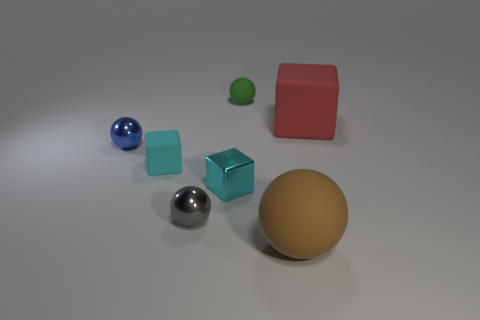How big is the metallic ball that is on the right side of the tiny blue shiny object?
Your response must be concise. Small. How many yellow things are big matte cubes or spheres?
Keep it short and to the point. 0. Are there any other things that are made of the same material as the green sphere?
Your answer should be compact. Yes. There is a blue thing that is the same shape as the brown object; what material is it?
Give a very brief answer. Metal. Are there the same number of big brown rubber balls that are in front of the large sphere and green rubber things?
Provide a succinct answer. No. What size is the cube that is to the right of the gray thing and left of the red thing?
Your answer should be compact. Small. Is there anything else of the same color as the small matte cube?
Give a very brief answer. Yes. What size is the rubber sphere behind the tiny cube behind the shiny block?
Offer a very short reply. Small. What color is the cube that is right of the tiny cyan matte object and behind the cyan shiny cube?
Your response must be concise. Red. How many other objects are the same size as the cyan shiny cube?
Ensure brevity in your answer.  4. 